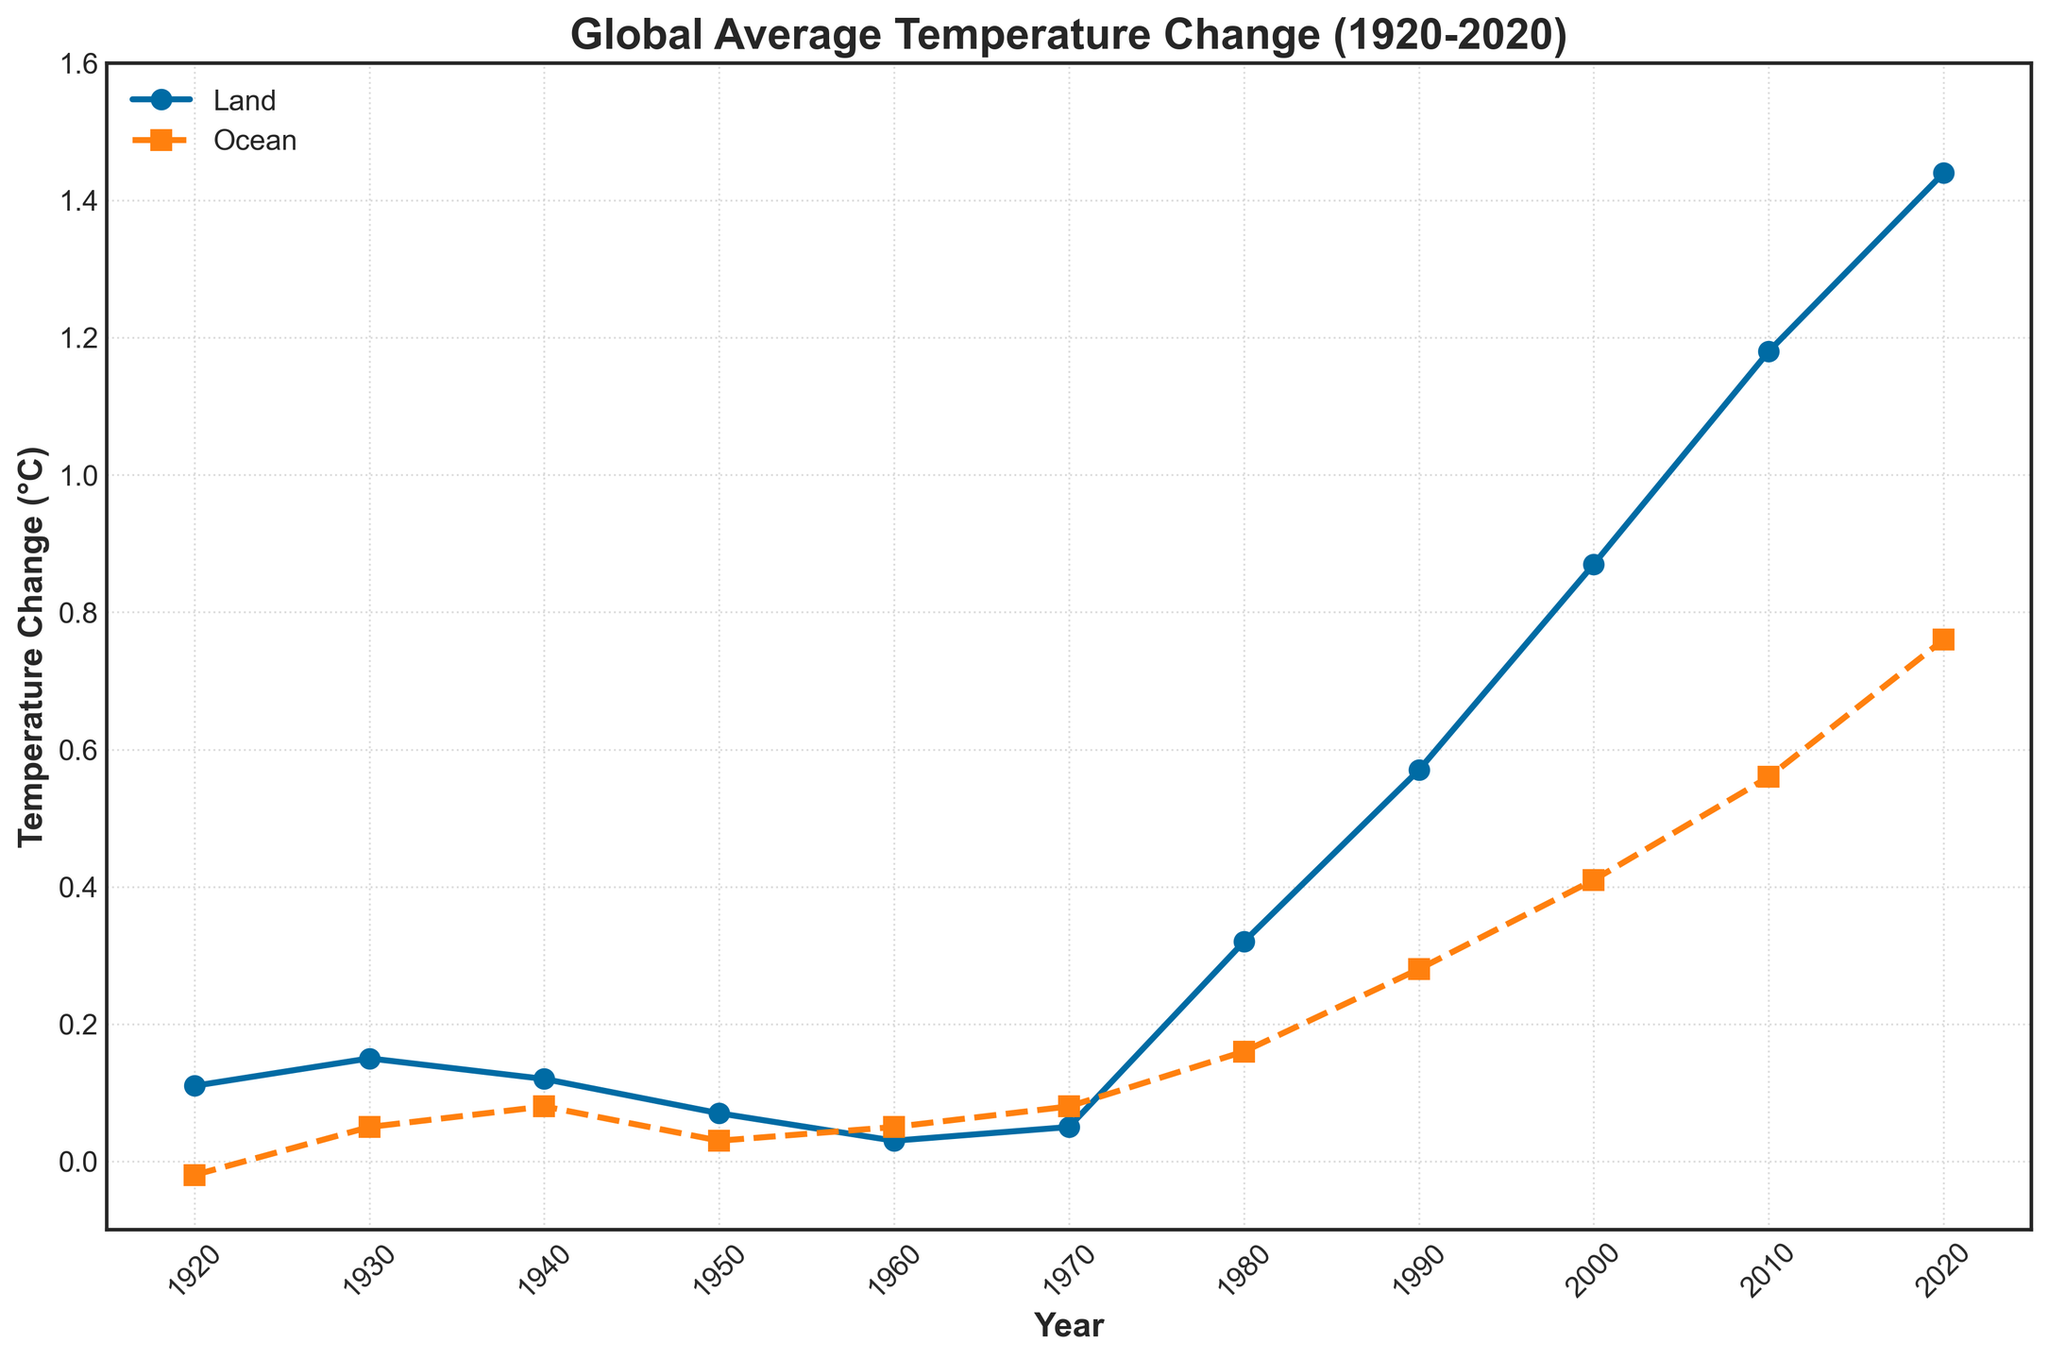What's the temperature change for the land in 1960? Locate the data point corresponding to the year 1960 on the land temperature change line. The value is 0.03°C.
Answer: 0.03°C How much did the ocean temperature change in 2020 compared to 1930? Subtract the ocean temperature change in 1930 from the value in 2020 (0.76 - 0.05). The change is 0.71°C.
Answer: 0.71°C What is the difference between land and ocean temperature change in 2010? Subtract the ocean temperature change in 2010 from the land temperature change in 2010 (1.18 - 0.56). The difference is 0.62°C.
Answer: 0.62°C Which decade saw the largest increase in land temperature change? Identify the decade with the greatest increase in the land temperature change. The largest increase is from 2000 to 2010 (1.18 - 0.87 = 0.31°C).
Answer: 2000s During which periods did the ocean temperature change remain constant or decrease? Look for flat or negative slopes in the ocean temperature change line. The temperature remained relatively constant or decreased between 1920-1930 and 1960-1970.
Answer: 1920-1930 and 1960-1970 Which has a higher temperature change in 1980, land or ocean? Compare the data points for 1980. The land temperature change is 0.32°C, while the ocean temperature change is 0.16°C. The land has a higher change.
Answer: Land How much did the average temperature change for both land and ocean from 1920 to 2020? Calculate the average change by adding the final values for both the land and ocean and then dividing by 2 ((1.44 + 0.76) / 2 = 1.10°C).
Answer: 1.10°C Describe the overall trend seen in land and ocean temperature changes over the past century. Observe the overall pattern in both lines, identifying upward trends. Both land and ocean temperatures increased significantly over the past century, with land temperatures rising faster.
Answer: Both increased, land more rapidly Is there any year where the land and ocean temperature changes are equal? Check if any data points for land and ocean temperature changes coincide. No years exhibit equal temperature changes for land and ocean.
Answer: No What year had the lowest land temperature change? Identify the data point with the smallest value on the land temperature change line. The lowest value is 0.03°C in 1960.
Answer: 1960 